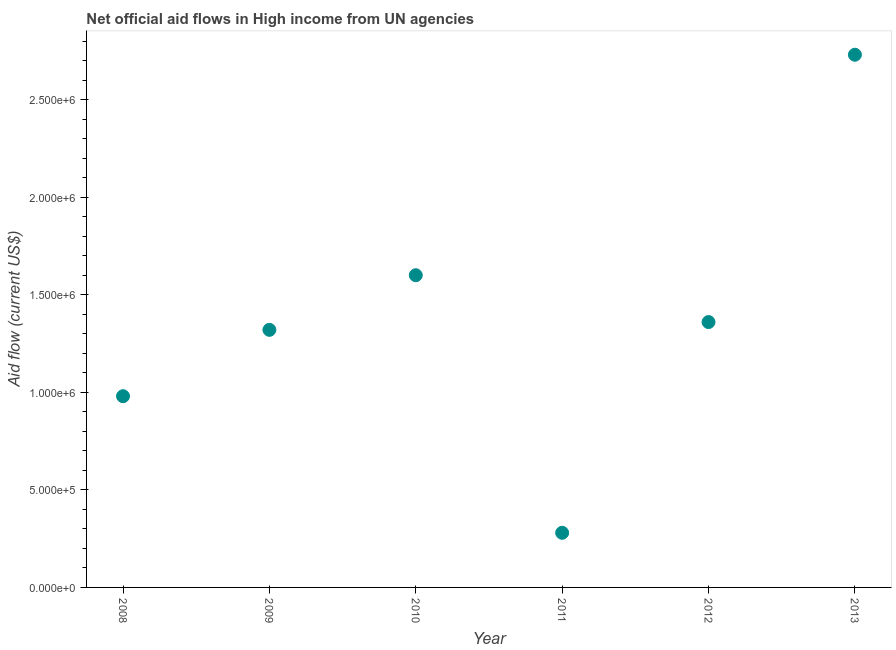What is the net official flows from un agencies in 2012?
Your answer should be compact. 1.36e+06. Across all years, what is the maximum net official flows from un agencies?
Provide a succinct answer. 2.73e+06. Across all years, what is the minimum net official flows from un agencies?
Your response must be concise. 2.80e+05. What is the sum of the net official flows from un agencies?
Your answer should be very brief. 8.27e+06. What is the difference between the net official flows from un agencies in 2011 and 2013?
Provide a short and direct response. -2.45e+06. What is the average net official flows from un agencies per year?
Ensure brevity in your answer.  1.38e+06. What is the median net official flows from un agencies?
Offer a very short reply. 1.34e+06. Do a majority of the years between 2009 and 2010 (inclusive) have net official flows from un agencies greater than 1400000 US$?
Offer a very short reply. No. What is the ratio of the net official flows from un agencies in 2012 to that in 2013?
Offer a terse response. 0.5. Is the difference between the net official flows from un agencies in 2009 and 2010 greater than the difference between any two years?
Ensure brevity in your answer.  No. What is the difference between the highest and the second highest net official flows from un agencies?
Give a very brief answer. 1.13e+06. What is the difference between the highest and the lowest net official flows from un agencies?
Provide a succinct answer. 2.45e+06. Does the net official flows from un agencies monotonically increase over the years?
Offer a terse response. No. What is the difference between two consecutive major ticks on the Y-axis?
Give a very brief answer. 5.00e+05. Are the values on the major ticks of Y-axis written in scientific E-notation?
Ensure brevity in your answer.  Yes. What is the title of the graph?
Your answer should be compact. Net official aid flows in High income from UN agencies. What is the Aid flow (current US$) in 2008?
Give a very brief answer. 9.80e+05. What is the Aid flow (current US$) in 2009?
Ensure brevity in your answer.  1.32e+06. What is the Aid flow (current US$) in 2010?
Provide a short and direct response. 1.60e+06. What is the Aid flow (current US$) in 2012?
Ensure brevity in your answer.  1.36e+06. What is the Aid flow (current US$) in 2013?
Ensure brevity in your answer.  2.73e+06. What is the difference between the Aid flow (current US$) in 2008 and 2010?
Give a very brief answer. -6.20e+05. What is the difference between the Aid flow (current US$) in 2008 and 2011?
Your response must be concise. 7.00e+05. What is the difference between the Aid flow (current US$) in 2008 and 2012?
Offer a terse response. -3.80e+05. What is the difference between the Aid flow (current US$) in 2008 and 2013?
Make the answer very short. -1.75e+06. What is the difference between the Aid flow (current US$) in 2009 and 2010?
Offer a very short reply. -2.80e+05. What is the difference between the Aid flow (current US$) in 2009 and 2011?
Ensure brevity in your answer.  1.04e+06. What is the difference between the Aid flow (current US$) in 2009 and 2013?
Ensure brevity in your answer.  -1.41e+06. What is the difference between the Aid flow (current US$) in 2010 and 2011?
Your answer should be compact. 1.32e+06. What is the difference between the Aid flow (current US$) in 2010 and 2013?
Offer a terse response. -1.13e+06. What is the difference between the Aid flow (current US$) in 2011 and 2012?
Make the answer very short. -1.08e+06. What is the difference between the Aid flow (current US$) in 2011 and 2013?
Give a very brief answer. -2.45e+06. What is the difference between the Aid flow (current US$) in 2012 and 2013?
Offer a very short reply. -1.37e+06. What is the ratio of the Aid flow (current US$) in 2008 to that in 2009?
Provide a short and direct response. 0.74. What is the ratio of the Aid flow (current US$) in 2008 to that in 2010?
Keep it short and to the point. 0.61. What is the ratio of the Aid flow (current US$) in 2008 to that in 2012?
Provide a succinct answer. 0.72. What is the ratio of the Aid flow (current US$) in 2008 to that in 2013?
Provide a short and direct response. 0.36. What is the ratio of the Aid flow (current US$) in 2009 to that in 2010?
Offer a terse response. 0.82. What is the ratio of the Aid flow (current US$) in 2009 to that in 2011?
Provide a short and direct response. 4.71. What is the ratio of the Aid flow (current US$) in 2009 to that in 2012?
Make the answer very short. 0.97. What is the ratio of the Aid flow (current US$) in 2009 to that in 2013?
Offer a very short reply. 0.48. What is the ratio of the Aid flow (current US$) in 2010 to that in 2011?
Offer a terse response. 5.71. What is the ratio of the Aid flow (current US$) in 2010 to that in 2012?
Give a very brief answer. 1.18. What is the ratio of the Aid flow (current US$) in 2010 to that in 2013?
Your answer should be very brief. 0.59. What is the ratio of the Aid flow (current US$) in 2011 to that in 2012?
Provide a succinct answer. 0.21. What is the ratio of the Aid flow (current US$) in 2011 to that in 2013?
Give a very brief answer. 0.1. What is the ratio of the Aid flow (current US$) in 2012 to that in 2013?
Offer a very short reply. 0.5. 